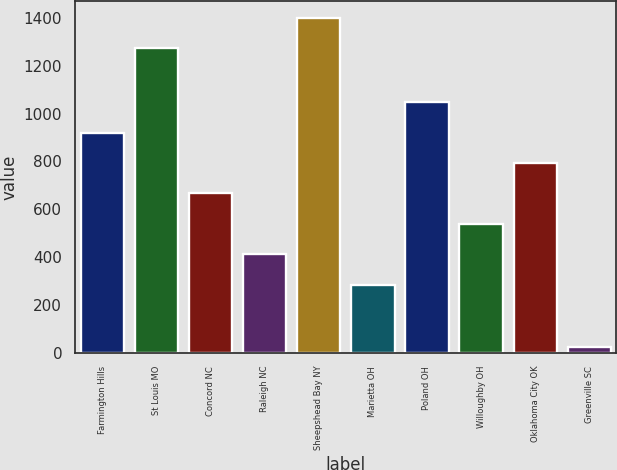Convert chart to OTSL. <chart><loc_0><loc_0><loc_500><loc_500><bar_chart><fcel>Farmington Hills<fcel>St Louis MO<fcel>Concord NC<fcel>Raleigh NC<fcel>Sheepshead Bay NY<fcel>Marietta OH<fcel>Poland OH<fcel>Willoughby OH<fcel>Oklahoma City OK<fcel>Greenville SC<nl><fcel>920.8<fcel>1274<fcel>666.2<fcel>411.6<fcel>1401.3<fcel>284.3<fcel>1048.1<fcel>538.9<fcel>793.5<fcel>22<nl></chart> 